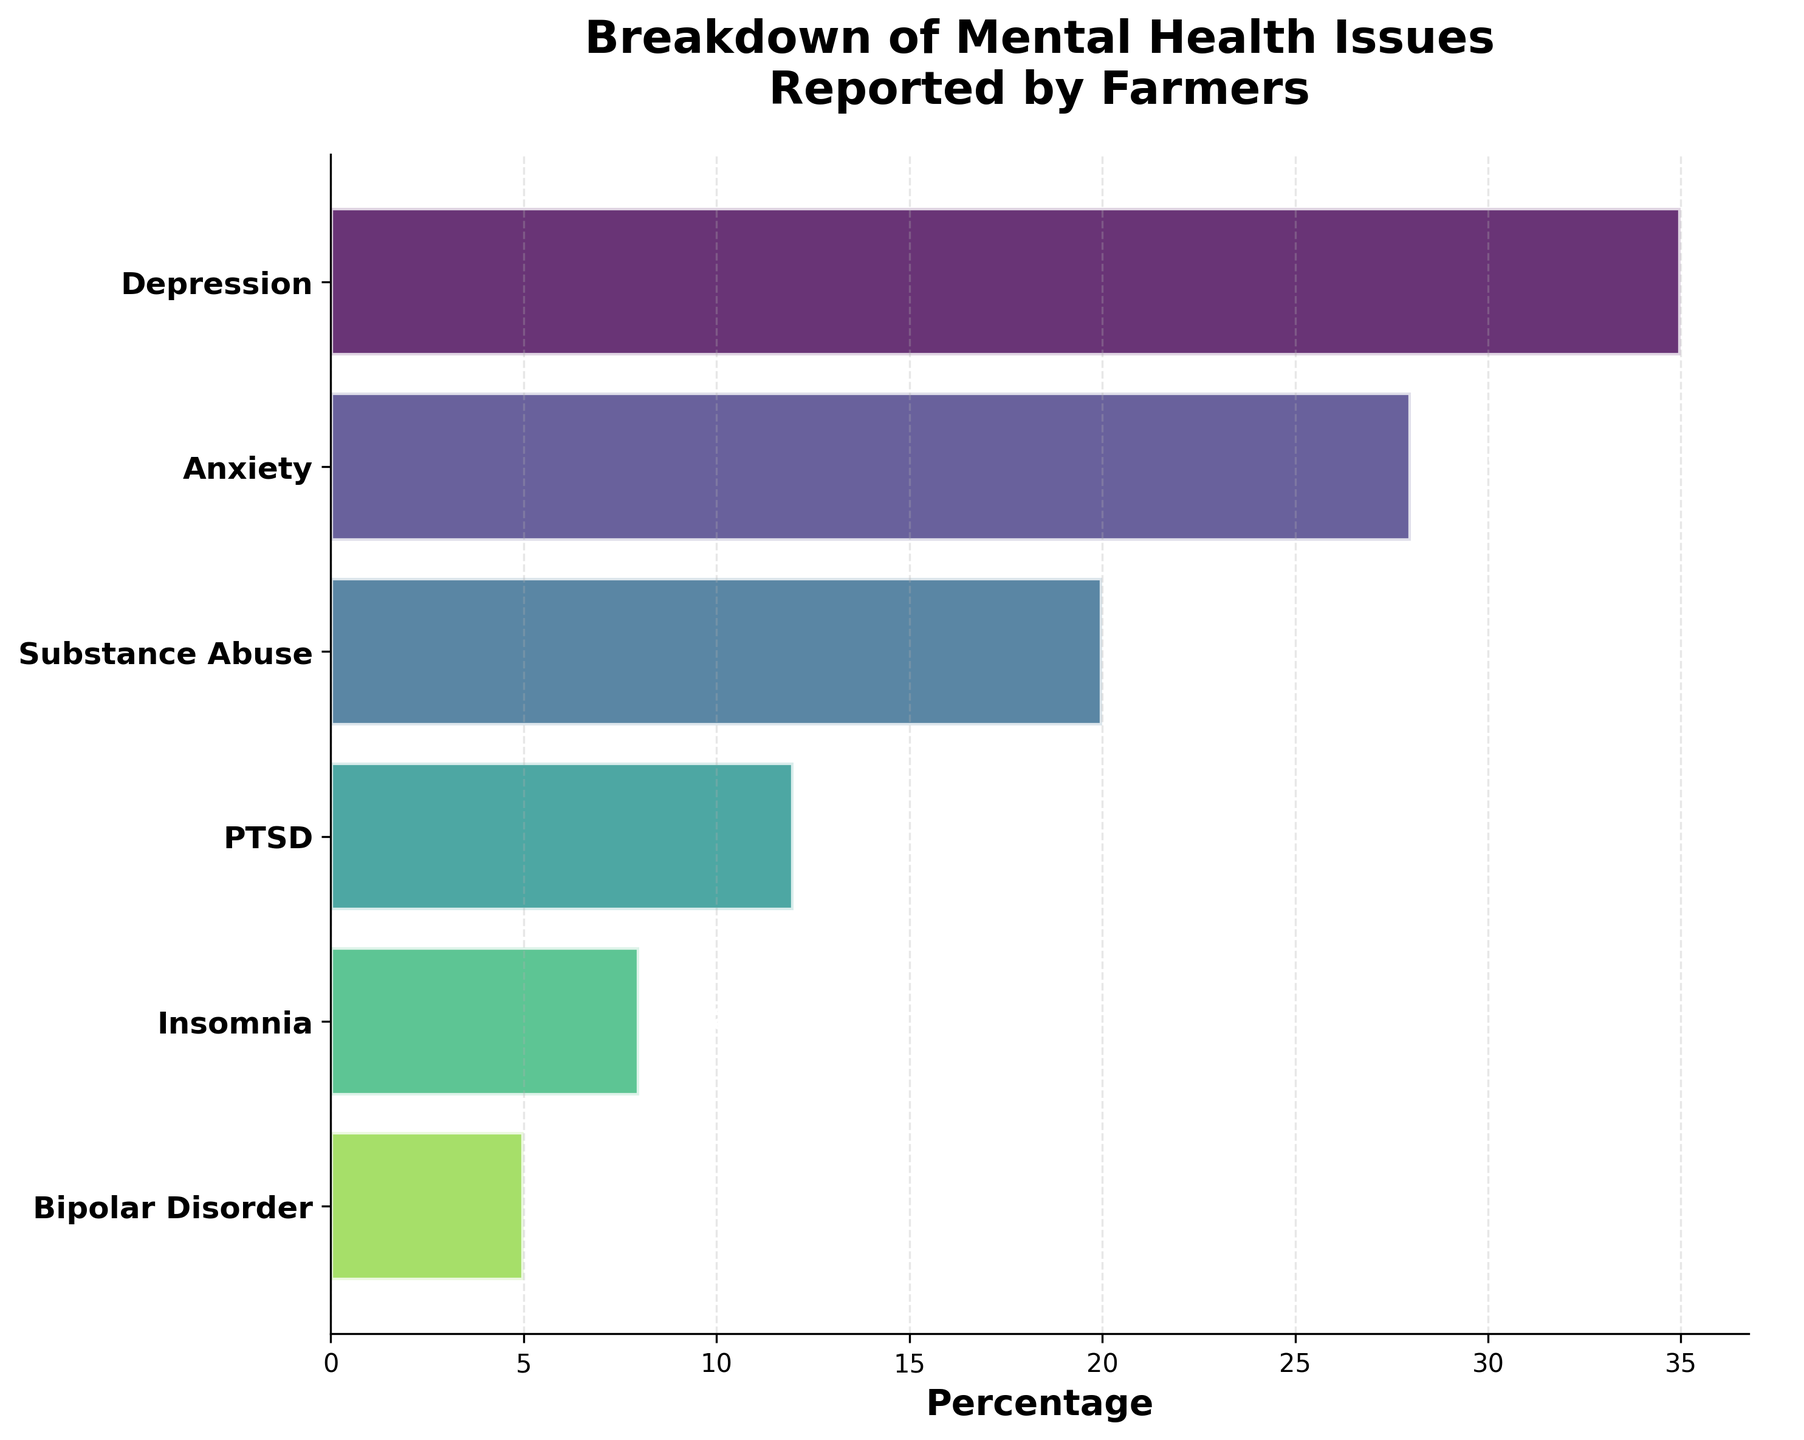What's the most common mental health issue reported by farmers? The first bar at the top of the funnel chart indicates the most common mental health issue. According to the chart, this is Depression.
Answer: Depression What percentage of farmers report Insomnia? To find the percentage of farmers reporting Insomnia, we refer to the bar labeled Insomnia in the funnel chart. The percentage is displayed next to the bar and is also shown as 8%.
Answer: 8% Which mental health issue has a higher percentage: PTSD or Bipolar Disorder? The funnel chart shows PTSD at 12% and Bipolar Disorder at 5%. By comparing these two percentages, we see that PTSD has a higher reported percentage.
Answer: PTSD How many types of mental health issues are reported by farmers in the chart? To determine the number of reported mental health issues, count the distinct bars in the funnel chart. There are six bars, each representing a different issue.
Answer: 6 What percentage of farmers reported Anxiety? Locate the Anxiety bar in the funnel chart and read the percentage next to it. According to the chart, the percentage of farmers reporting Anxiety is 28%.
Answer: 28% What is the combined percentage of Depression and Anxiety reported by farmers? To find the combined percentage of Depression (35%) and Anxiety (28%), add these percentages together: 35% + 28% = 63%.
Answer: 63% By how much is Substance Abuse more common than Insomnia among farmers? Substance Abuse is at 20% while Insomnia is at 8%. Subtract the percentage of Insomnia from Substance Abuse to get the difference: 20% - 8% = 12%.
Answer: 12% Which mental health issue is reported by the least percentage of farmers? The issue at the bottom of the funnel chart represents the least reported mental health issue. According to the chart, this is Bipolar Disorder at 5%.
Answer: Bipolar Disorder What is the difference in percentage between Anxiety and PTSD? The chart shows Anxiety at 28% and PTSD at 12%. To find the difference, subtract PTSD's percentage from Anxiety’s percentage: 28% - 12% = 16%.
Answer: 16% What is the proportion of farmers reporting Substance Abuse compared to those reporting Bipolar Disorder? Substance Abuse is at 20% and Bipolar Disorder is at 5%. To find the proportion, divide Substance Abuse’s percentage by Bipolar Disorder’s percentage: 20% / 5% = 4. This means Substance Abuse is reported four times more than Bipolar Disorder.
Answer: 4 